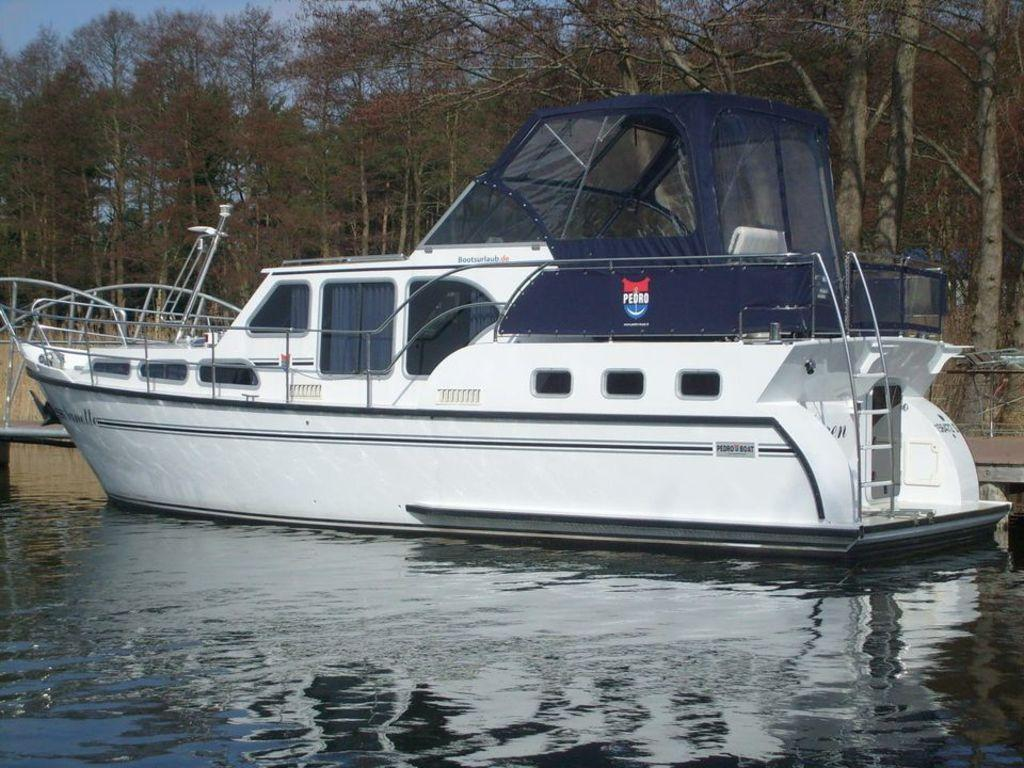What is the main subject of the image? The main subject of the image is water. What is floating on the water? There is a white-colored boat on the water. What can be seen in the background of the image? There are trees and the sky visible in the background of the image. What type of camera is being used to take the picture of the boat? There is no information about a camera being used to take the picture, as the focus is on the image itself. 